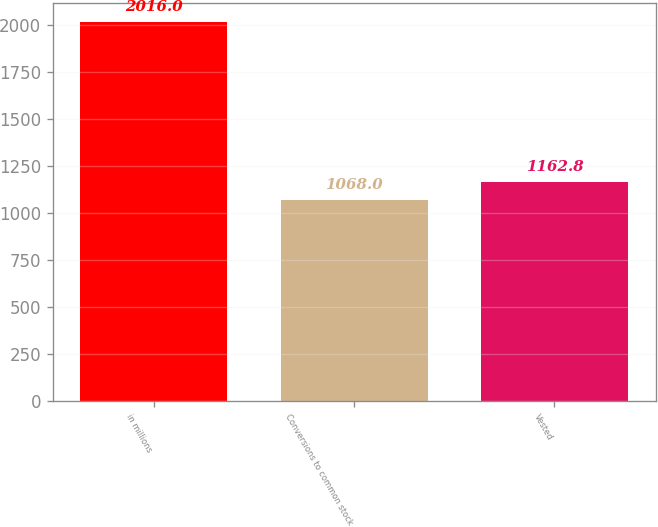Convert chart. <chart><loc_0><loc_0><loc_500><loc_500><bar_chart><fcel>in millions<fcel>Conversions to common stock<fcel>Vested<nl><fcel>2016<fcel>1068<fcel>1162.8<nl></chart> 